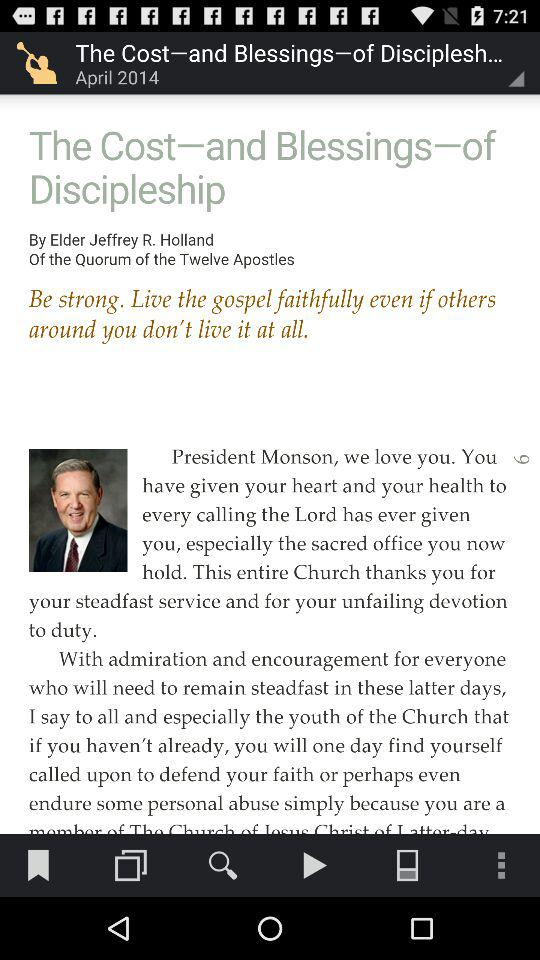When was the article updated? The article was last updated on April 2014. 